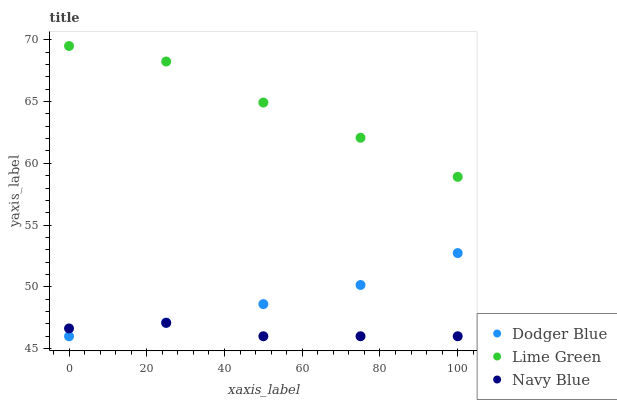Does Navy Blue have the minimum area under the curve?
Answer yes or no. Yes. Does Lime Green have the maximum area under the curve?
Answer yes or no. Yes. Does Dodger Blue have the minimum area under the curve?
Answer yes or no. No. Does Dodger Blue have the maximum area under the curve?
Answer yes or no. No. Is Dodger Blue the smoothest?
Answer yes or no. Yes. Is Lime Green the roughest?
Answer yes or no. Yes. Is Navy Blue the smoothest?
Answer yes or no. No. Is Navy Blue the roughest?
Answer yes or no. No. Does Dodger Blue have the lowest value?
Answer yes or no. Yes. Does Lime Green have the highest value?
Answer yes or no. Yes. Does Dodger Blue have the highest value?
Answer yes or no. No. Is Dodger Blue less than Lime Green?
Answer yes or no. Yes. Is Lime Green greater than Dodger Blue?
Answer yes or no. Yes. Does Navy Blue intersect Dodger Blue?
Answer yes or no. Yes. Is Navy Blue less than Dodger Blue?
Answer yes or no. No. Is Navy Blue greater than Dodger Blue?
Answer yes or no. No. Does Dodger Blue intersect Lime Green?
Answer yes or no. No. 